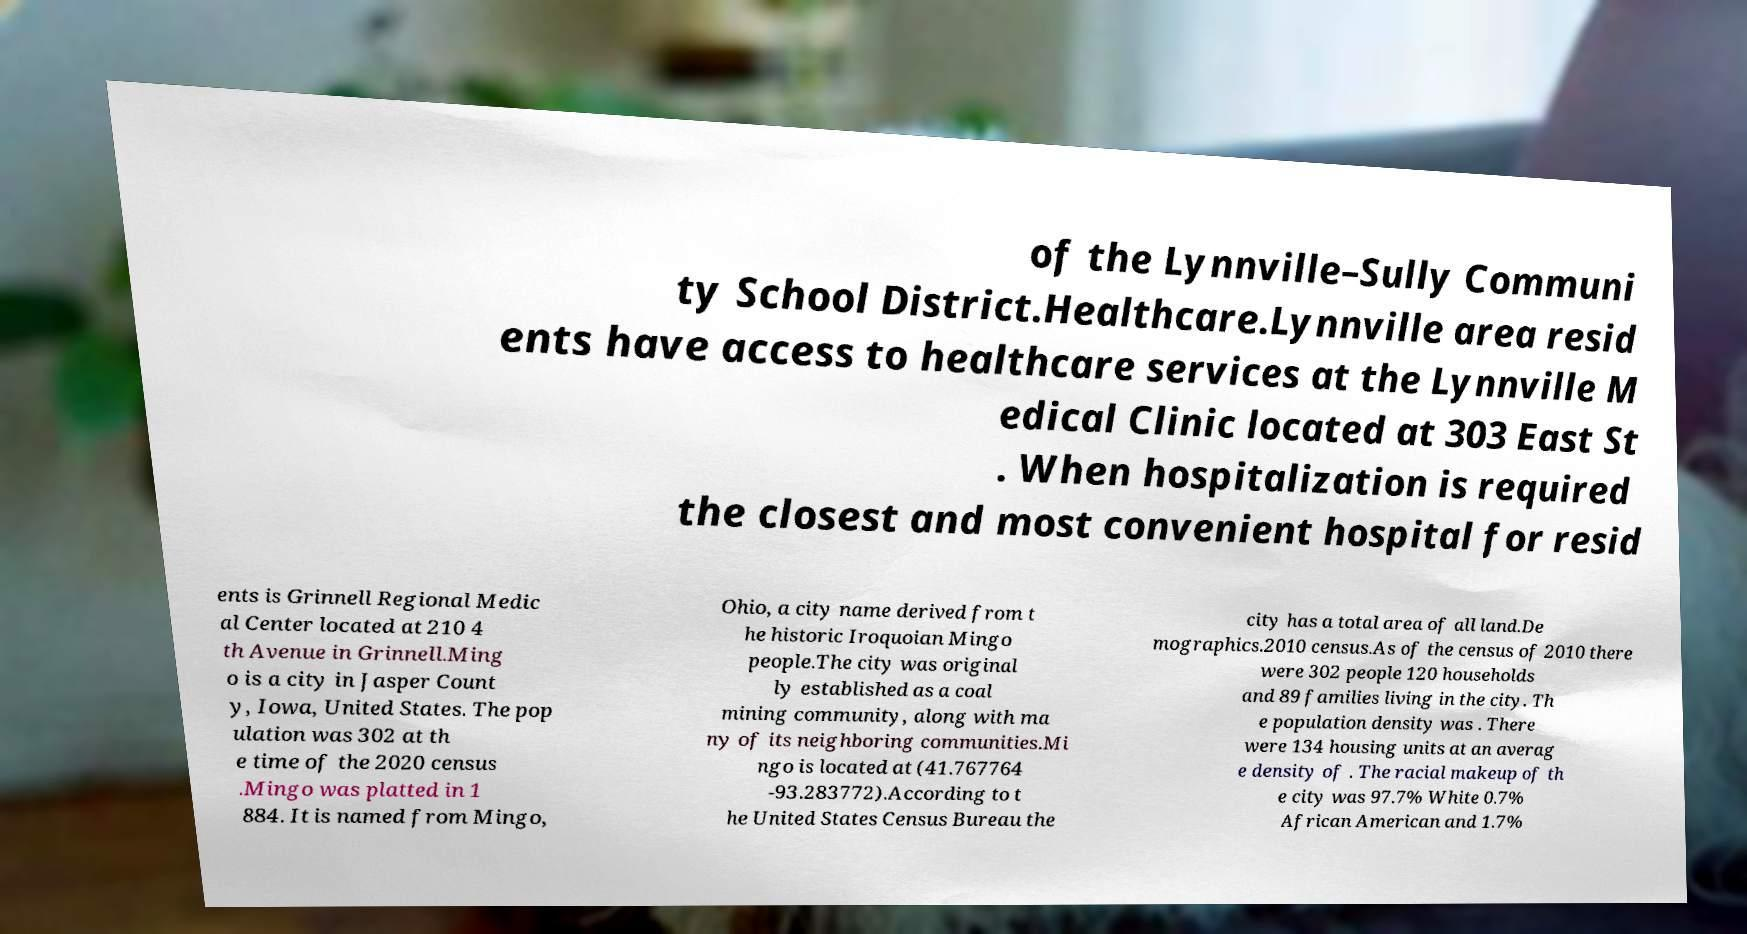There's text embedded in this image that I need extracted. Can you transcribe it verbatim? of the Lynnville–Sully Communi ty School District.Healthcare.Lynnville area resid ents have access to healthcare services at the Lynnville M edical Clinic located at 303 East St . When hospitalization is required the closest and most convenient hospital for resid ents is Grinnell Regional Medic al Center located at 210 4 th Avenue in Grinnell.Ming o is a city in Jasper Count y, Iowa, United States. The pop ulation was 302 at th e time of the 2020 census .Mingo was platted in 1 884. It is named from Mingo, Ohio, a city name derived from t he historic Iroquoian Mingo people.The city was original ly established as a coal mining community, along with ma ny of its neighboring communities.Mi ngo is located at (41.767764 -93.283772).According to t he United States Census Bureau the city has a total area of all land.De mographics.2010 census.As of the census of 2010 there were 302 people 120 households and 89 families living in the city. Th e population density was . There were 134 housing units at an averag e density of . The racial makeup of th e city was 97.7% White 0.7% African American and 1.7% 